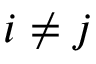Convert formula to latex. <formula><loc_0><loc_0><loc_500><loc_500>i \neq j</formula> 